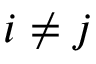Convert formula to latex. <formula><loc_0><loc_0><loc_500><loc_500>i \neq j</formula> 